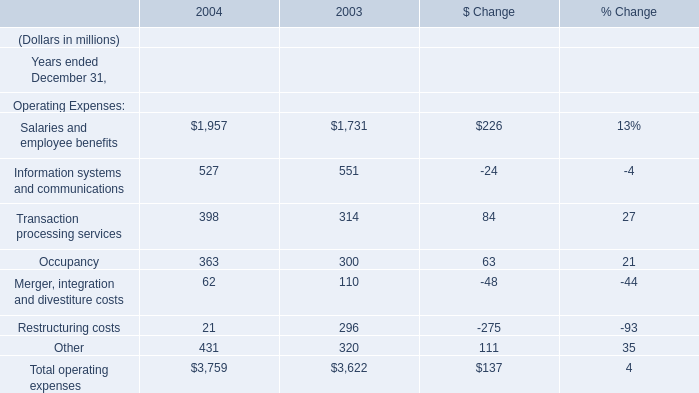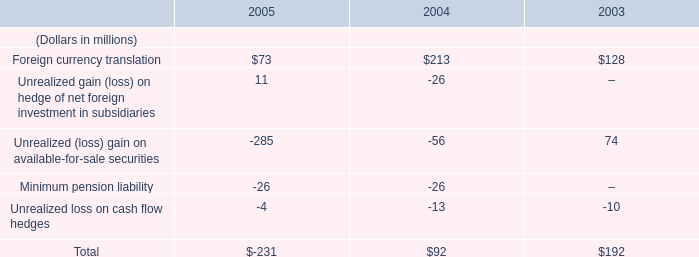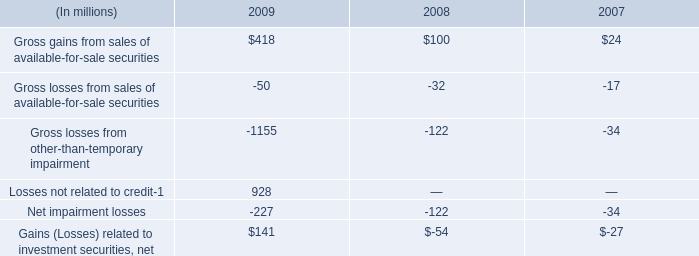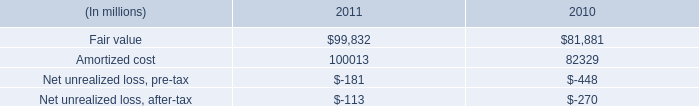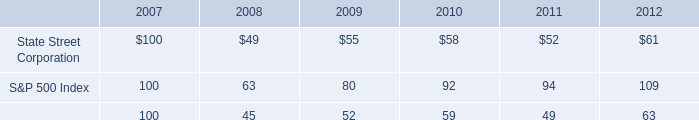what is the percent change in state street corporation's cumulative total shareholder return on common stock between 2008 and 2009? 
Computations: ((55 - 49) / 49)
Answer: 0.12245. 